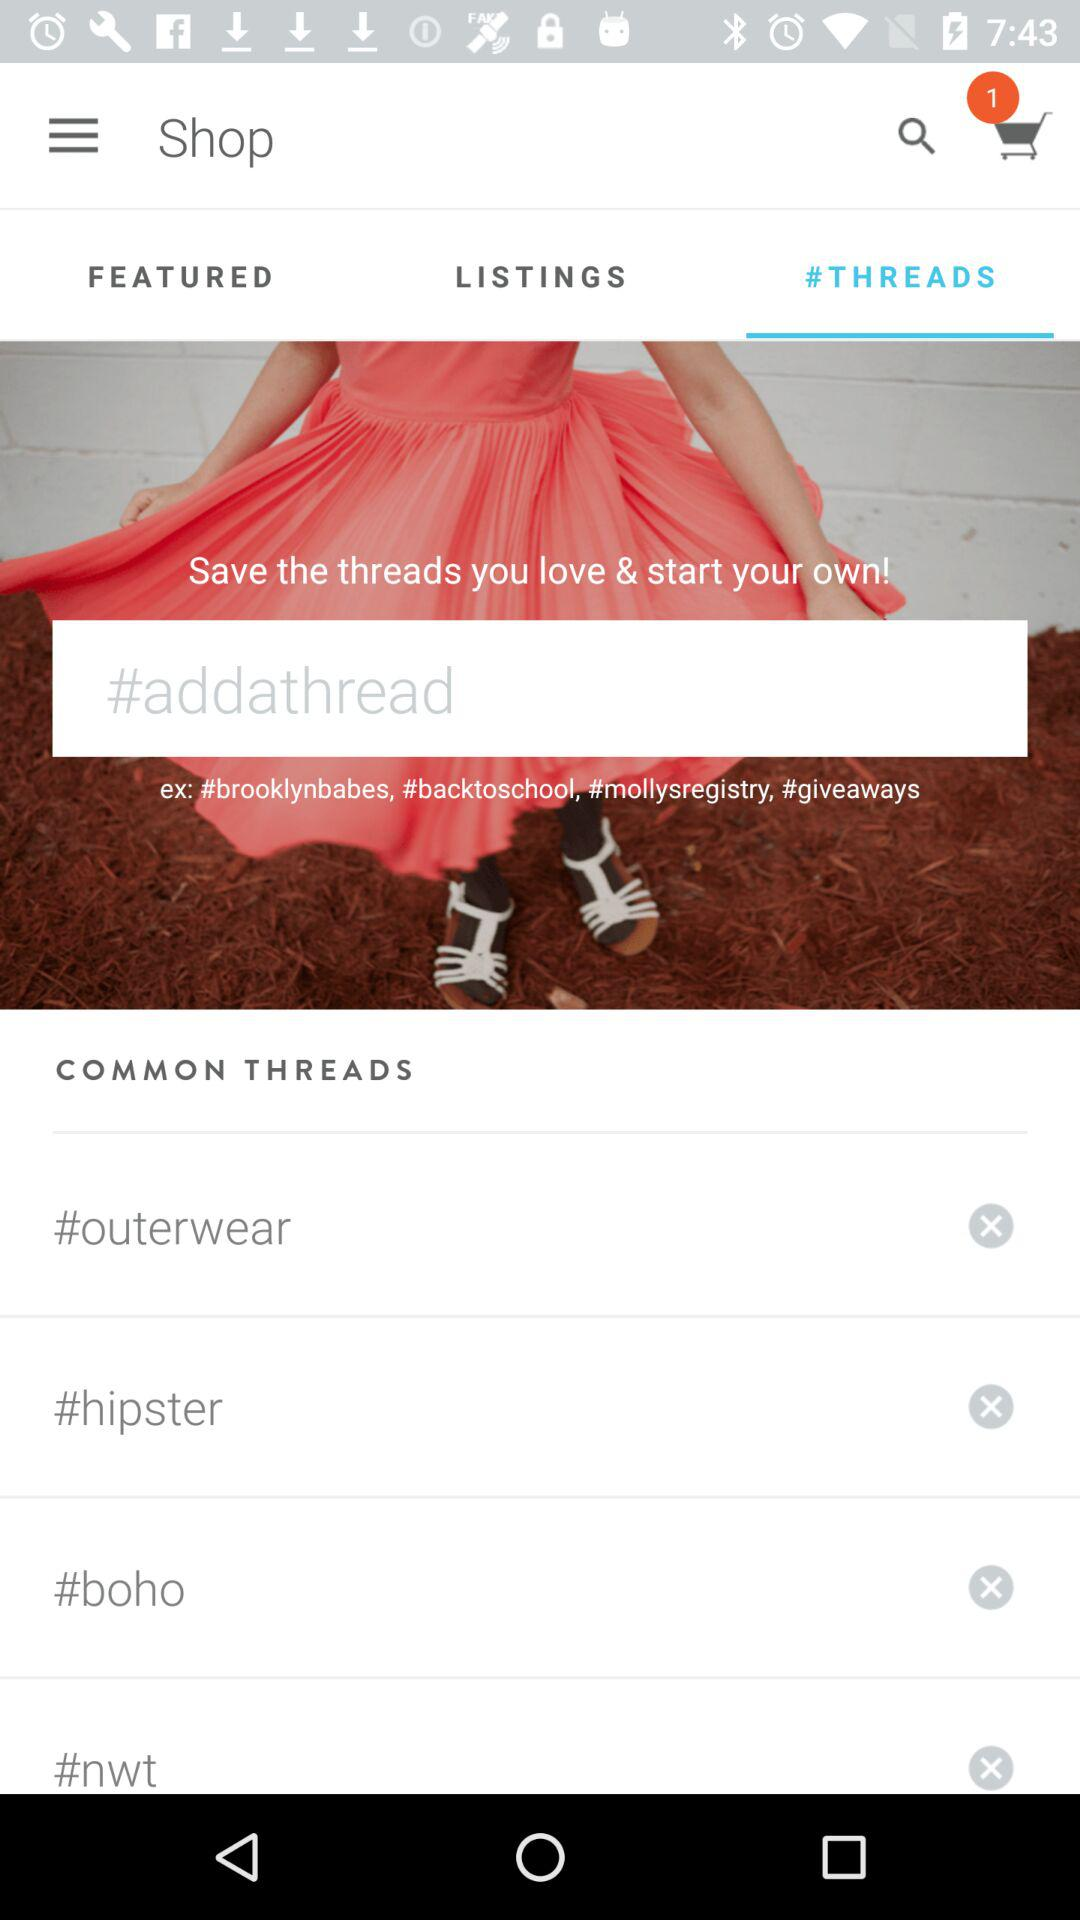How many items are in "FEATURED"?
When the provided information is insufficient, respond with <no answer>. <no answer> 